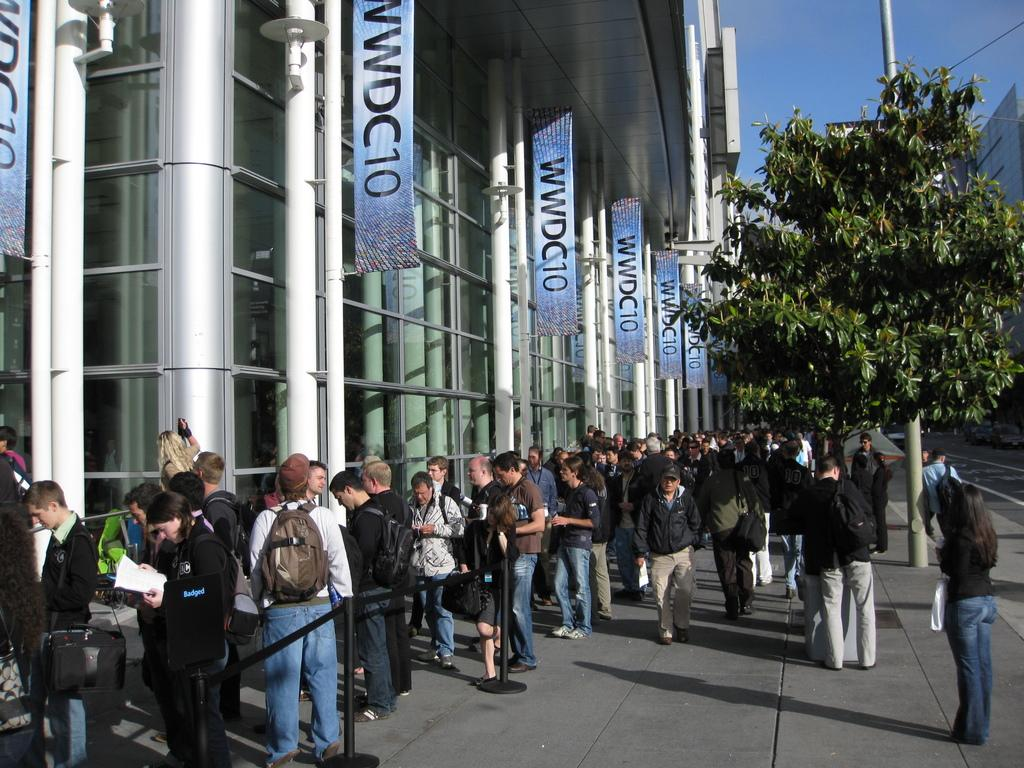<image>
Render a clear and concise summary of the photo. A large number of people stand in line for WWDC10. 